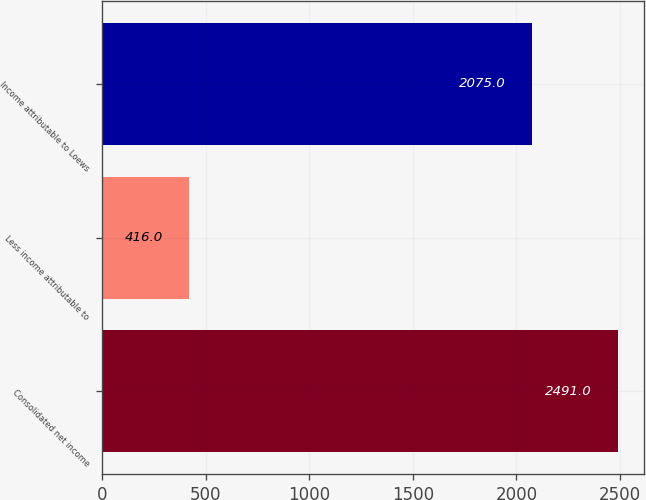Convert chart to OTSL. <chart><loc_0><loc_0><loc_500><loc_500><bar_chart><fcel>Consolidated net income<fcel>Less income attributable to<fcel>Income attributable to Loews<nl><fcel>2491<fcel>416<fcel>2075<nl></chart> 